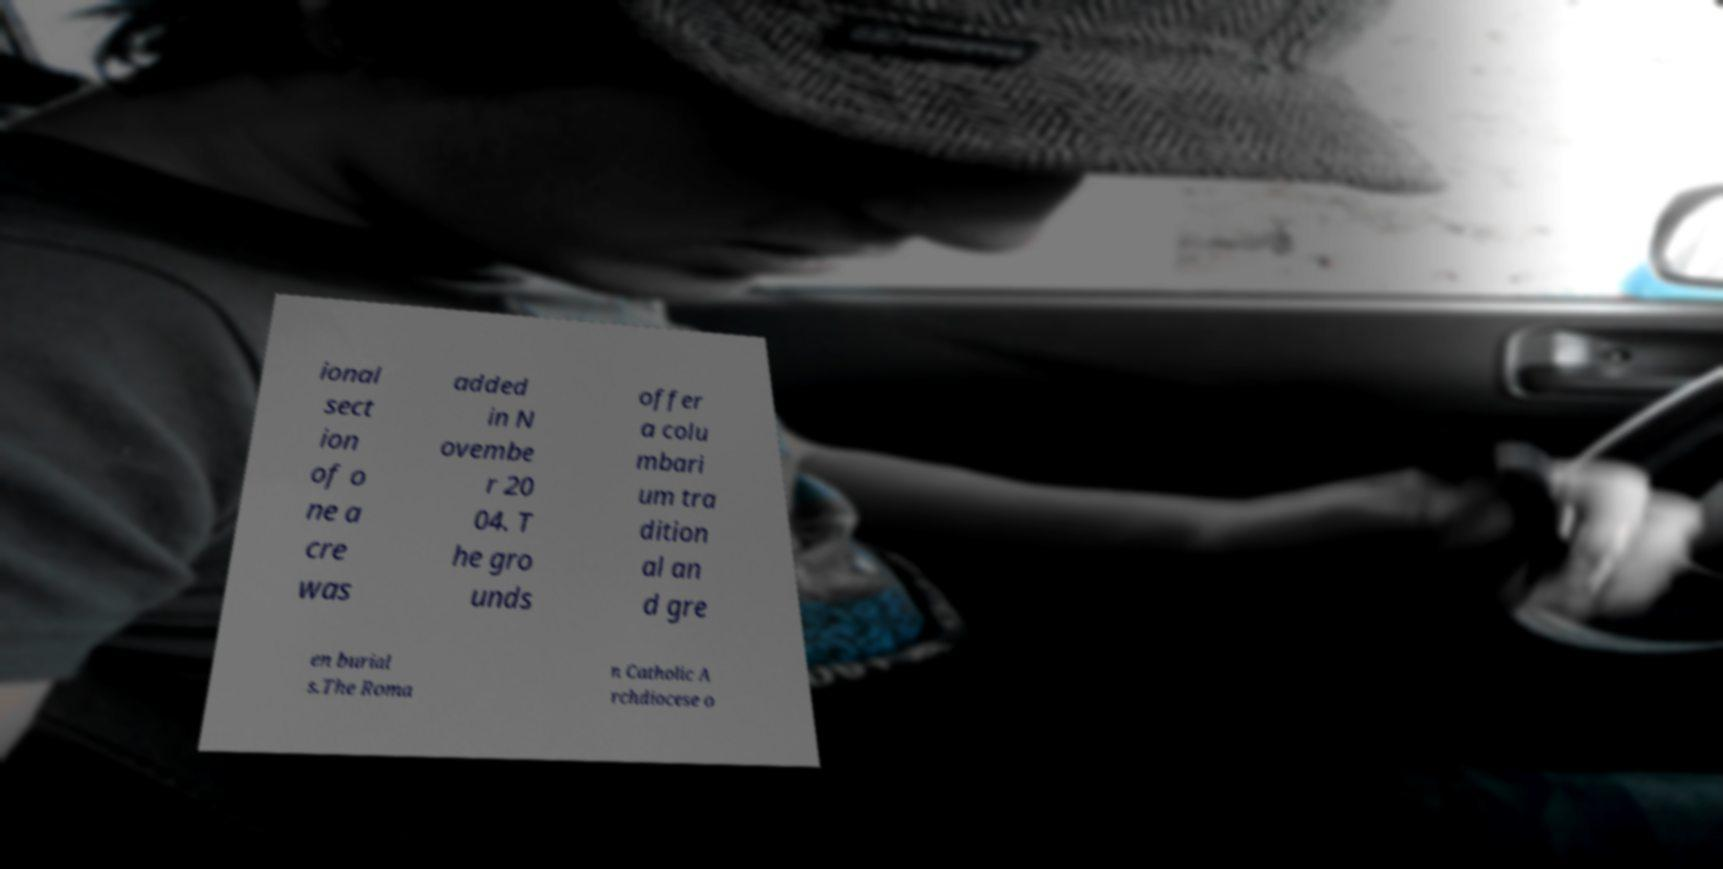For documentation purposes, I need the text within this image transcribed. Could you provide that? ional sect ion of o ne a cre was added in N ovembe r 20 04. T he gro unds offer a colu mbari um tra dition al an d gre en burial s.The Roma n Catholic A rchdiocese o 